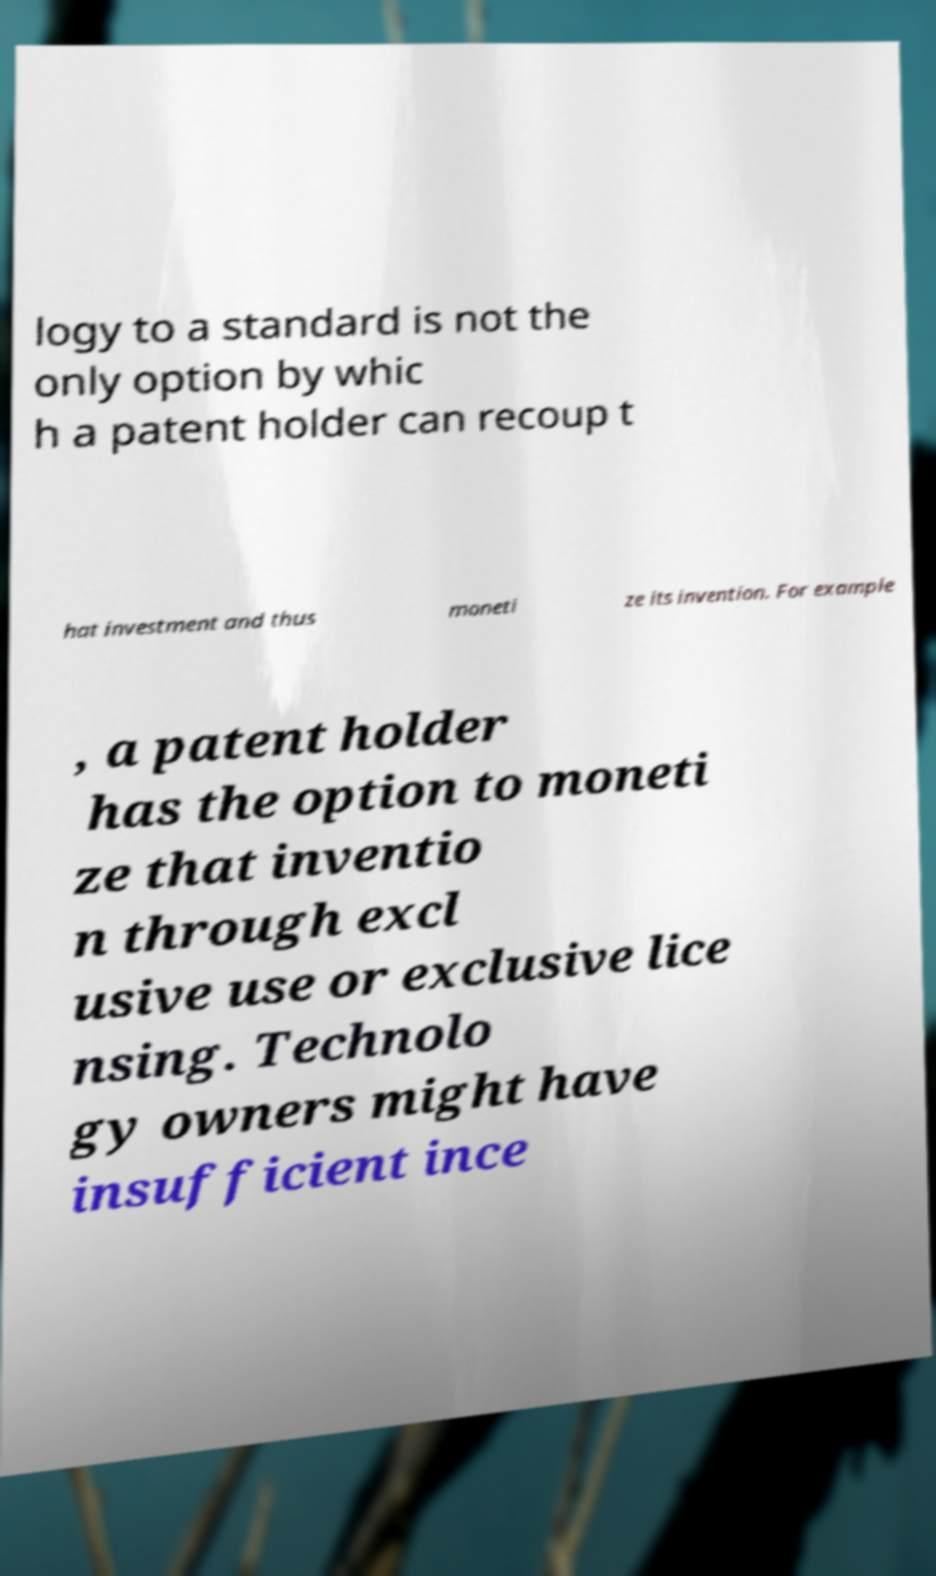I need the written content from this picture converted into text. Can you do that? logy to a standard is not the only option by whic h a patent holder can recoup t hat investment and thus moneti ze its invention. For example , a patent holder has the option to moneti ze that inventio n through excl usive use or exclusive lice nsing. Technolo gy owners might have insufficient ince 